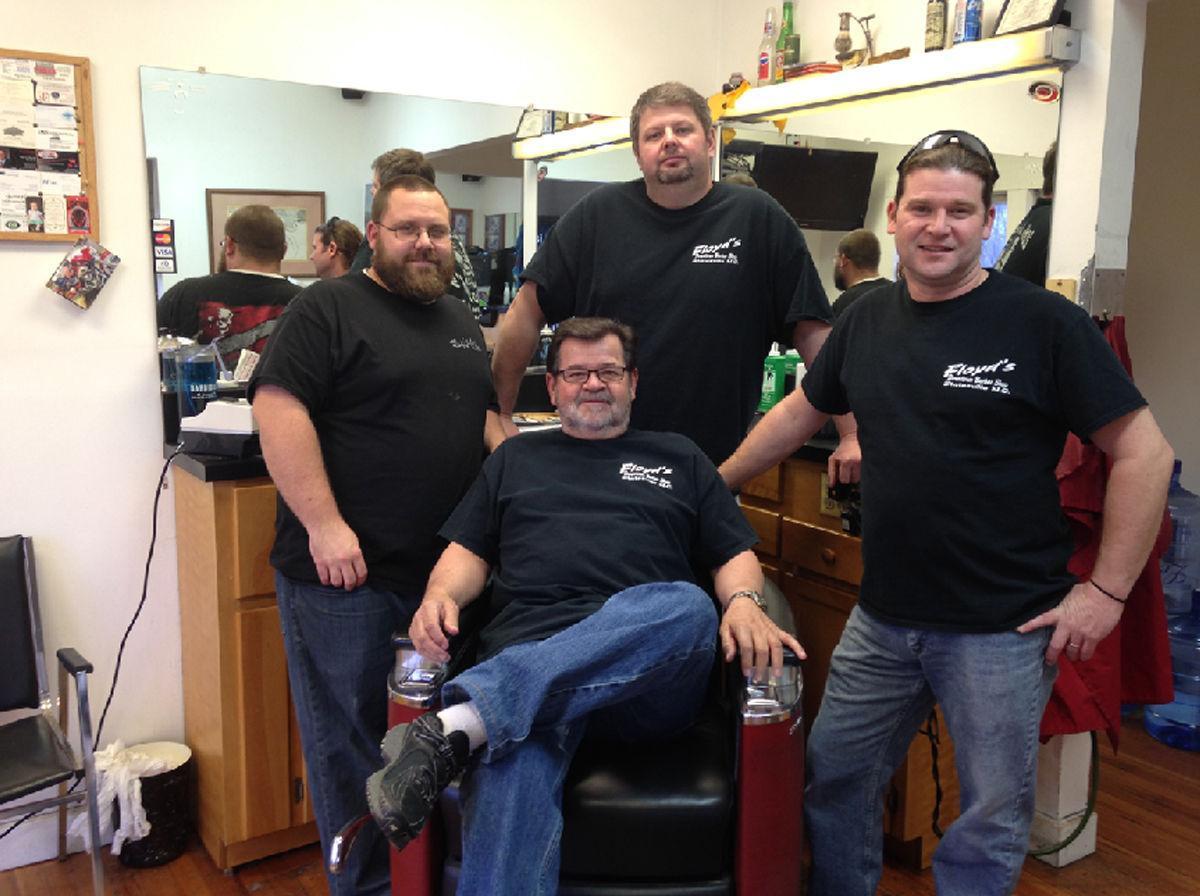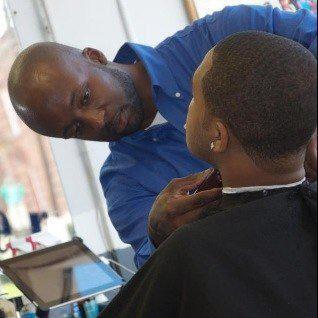The first image is the image on the left, the second image is the image on the right. Examine the images to the left and right. Is the description "One image is the outside of a barber shop and the other image is the inside of a barber shop." accurate? Answer yes or no. No. The first image is the image on the left, the second image is the image on the right. Evaluate the accuracy of this statement regarding the images: "A woman is cutting a male's hair in at least one of the images.". Is it true? Answer yes or no. No. 